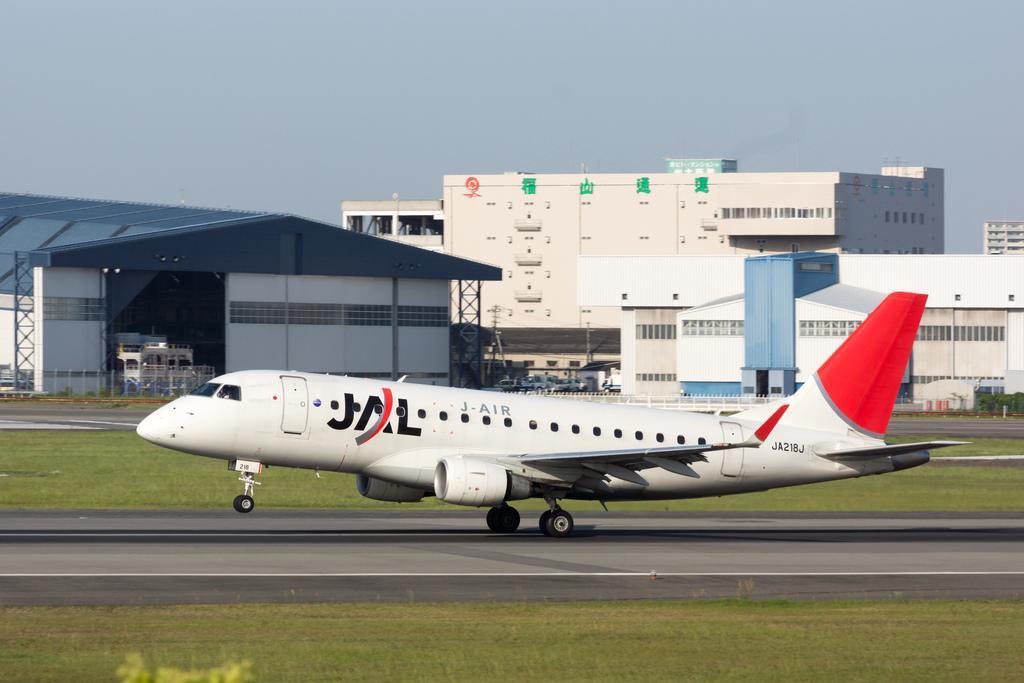Describe this image in one or two sentences. In this image in the center there is an airplane, and at the bottom there is a walkway and grass. In the background there are some buildings and some vehicles and also there is a fence. On the top of the image there is sky. 